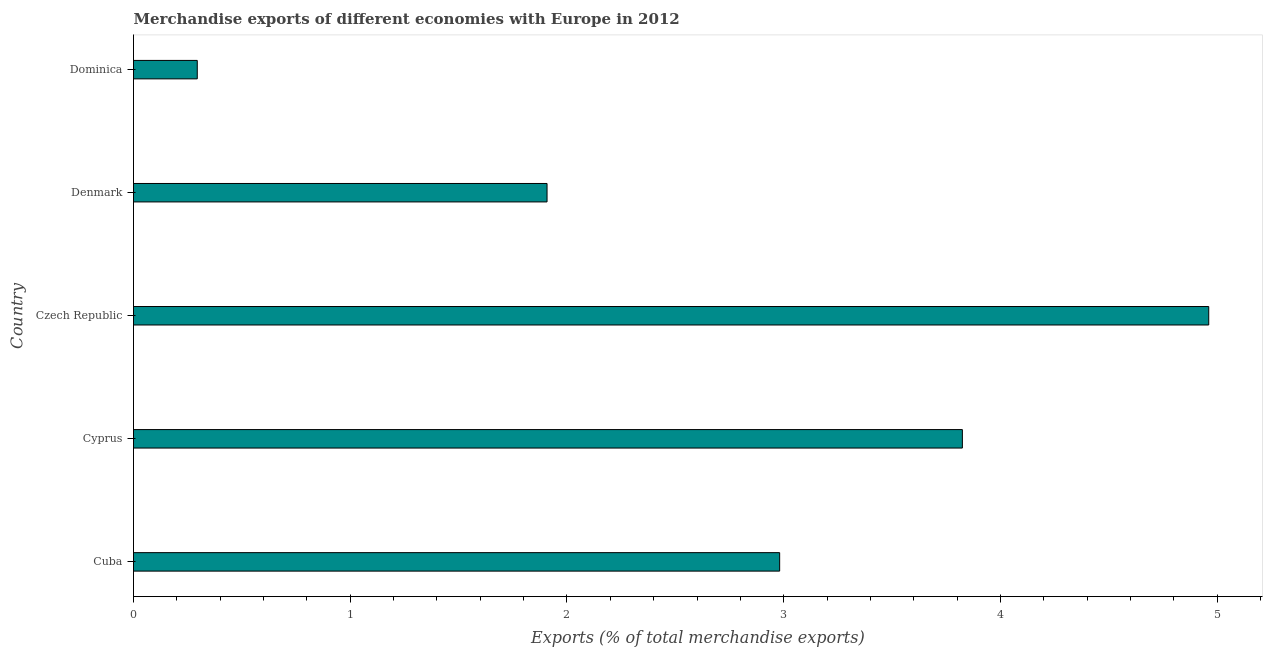Does the graph contain any zero values?
Give a very brief answer. No. What is the title of the graph?
Offer a terse response. Merchandise exports of different economies with Europe in 2012. What is the label or title of the X-axis?
Your response must be concise. Exports (% of total merchandise exports). What is the label or title of the Y-axis?
Provide a succinct answer. Country. What is the merchandise exports in Cyprus?
Your answer should be very brief. 3.82. Across all countries, what is the maximum merchandise exports?
Your response must be concise. 4.96. Across all countries, what is the minimum merchandise exports?
Your answer should be compact. 0.29. In which country was the merchandise exports maximum?
Your response must be concise. Czech Republic. In which country was the merchandise exports minimum?
Provide a succinct answer. Dominica. What is the sum of the merchandise exports?
Your answer should be compact. 13.97. What is the difference between the merchandise exports in Cuba and Cyprus?
Your answer should be very brief. -0.84. What is the average merchandise exports per country?
Your answer should be compact. 2.79. What is the median merchandise exports?
Provide a short and direct response. 2.98. In how many countries, is the merchandise exports greater than 0.4 %?
Keep it short and to the point. 4. What is the ratio of the merchandise exports in Czech Republic to that in Dominica?
Provide a succinct answer. 16.86. What is the difference between the highest and the second highest merchandise exports?
Provide a succinct answer. 1.14. Is the sum of the merchandise exports in Cyprus and Dominica greater than the maximum merchandise exports across all countries?
Offer a terse response. No. What is the difference between the highest and the lowest merchandise exports?
Offer a terse response. 4.67. How many bars are there?
Keep it short and to the point. 5. Are all the bars in the graph horizontal?
Your answer should be compact. Yes. How many countries are there in the graph?
Your response must be concise. 5. Are the values on the major ticks of X-axis written in scientific E-notation?
Keep it short and to the point. No. What is the Exports (% of total merchandise exports) in Cuba?
Provide a succinct answer. 2.98. What is the Exports (% of total merchandise exports) in Cyprus?
Provide a succinct answer. 3.82. What is the Exports (% of total merchandise exports) of Czech Republic?
Your answer should be very brief. 4.96. What is the Exports (% of total merchandise exports) of Denmark?
Provide a succinct answer. 1.91. What is the Exports (% of total merchandise exports) of Dominica?
Offer a very short reply. 0.29. What is the difference between the Exports (% of total merchandise exports) in Cuba and Cyprus?
Make the answer very short. -0.84. What is the difference between the Exports (% of total merchandise exports) in Cuba and Czech Republic?
Your answer should be very brief. -1.98. What is the difference between the Exports (% of total merchandise exports) in Cuba and Denmark?
Your response must be concise. 1.07. What is the difference between the Exports (% of total merchandise exports) in Cuba and Dominica?
Your response must be concise. 2.69. What is the difference between the Exports (% of total merchandise exports) in Cyprus and Czech Republic?
Ensure brevity in your answer.  -1.14. What is the difference between the Exports (% of total merchandise exports) in Cyprus and Denmark?
Provide a succinct answer. 1.92. What is the difference between the Exports (% of total merchandise exports) in Cyprus and Dominica?
Your answer should be very brief. 3.53. What is the difference between the Exports (% of total merchandise exports) in Czech Republic and Denmark?
Make the answer very short. 3.05. What is the difference between the Exports (% of total merchandise exports) in Czech Republic and Dominica?
Provide a short and direct response. 4.67. What is the difference between the Exports (% of total merchandise exports) in Denmark and Dominica?
Keep it short and to the point. 1.61. What is the ratio of the Exports (% of total merchandise exports) in Cuba to that in Cyprus?
Give a very brief answer. 0.78. What is the ratio of the Exports (% of total merchandise exports) in Cuba to that in Czech Republic?
Provide a succinct answer. 0.6. What is the ratio of the Exports (% of total merchandise exports) in Cuba to that in Denmark?
Your response must be concise. 1.56. What is the ratio of the Exports (% of total merchandise exports) in Cuba to that in Dominica?
Provide a succinct answer. 10.13. What is the ratio of the Exports (% of total merchandise exports) in Cyprus to that in Czech Republic?
Provide a succinct answer. 0.77. What is the ratio of the Exports (% of total merchandise exports) in Cyprus to that in Denmark?
Give a very brief answer. 2. What is the ratio of the Exports (% of total merchandise exports) in Czech Republic to that in Dominica?
Your answer should be very brief. 16.86. What is the ratio of the Exports (% of total merchandise exports) in Denmark to that in Dominica?
Your answer should be compact. 6.49. 